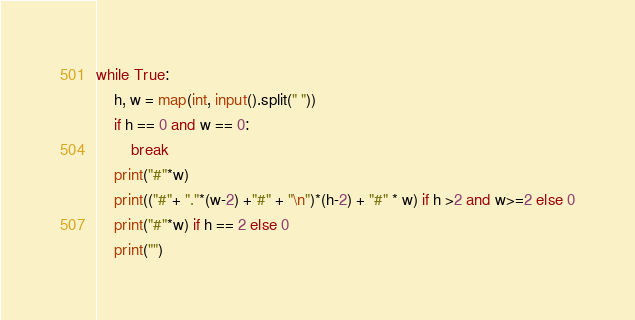Convert code to text. <code><loc_0><loc_0><loc_500><loc_500><_Python_>while True:
    h, w = map(int, input().split(" "))
    if h == 0 and w == 0:
        break
    print("#"*w)
    print(("#"+ "."*(w-2) +"#" + "\n")*(h-2) + "#" * w) if h >2 and w>=2 else 0
    print("#"*w) if h == 2 else 0
    print("")</code> 